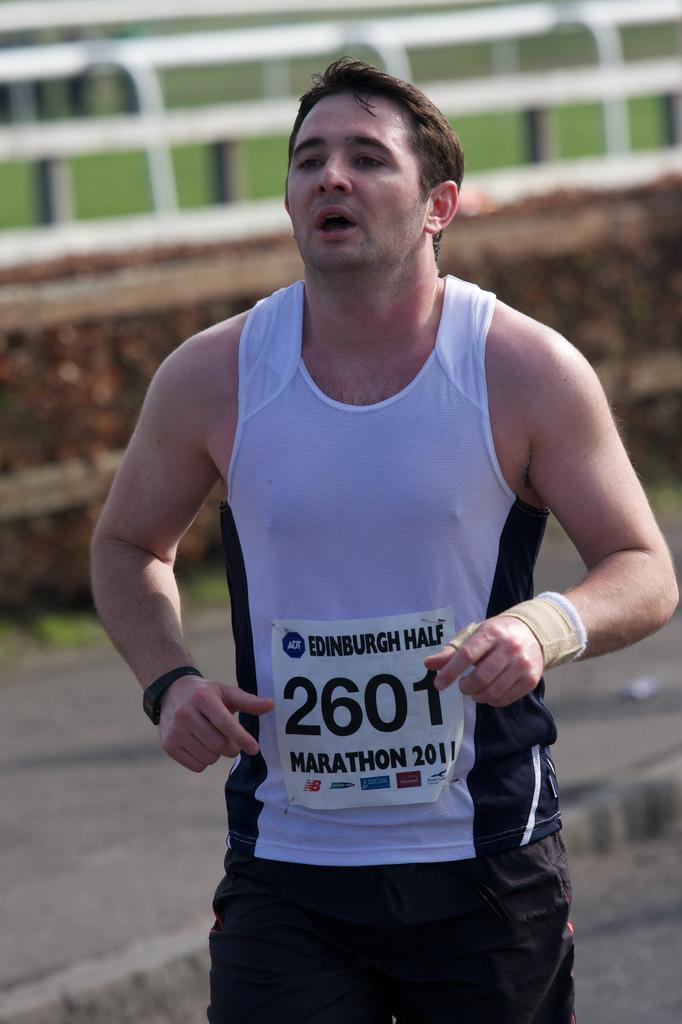Where was the image taken? The image is taken outdoors. What is the man in the image doing? The man is running on the road in the middle of the image. What can be seen in the background of the image? There is a wall with a railing and a ground with grass in the background. What trick is the man performing on the road in the image? There is no trick being performed by the man in the image; he is simply running on the road. 